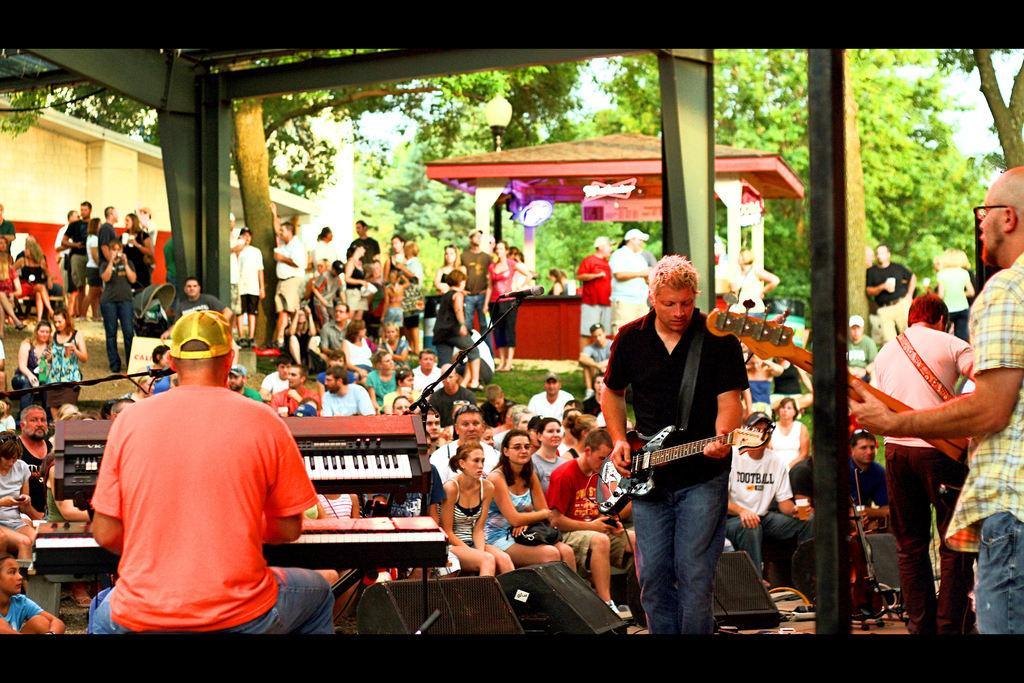How would you summarize this image in a sentence or two? In this picture we can see a crowd of people and in front we can see three persons playing musical instruments such as guitar, piano and here we have speakers and in the background we can see shade, light, tree. 